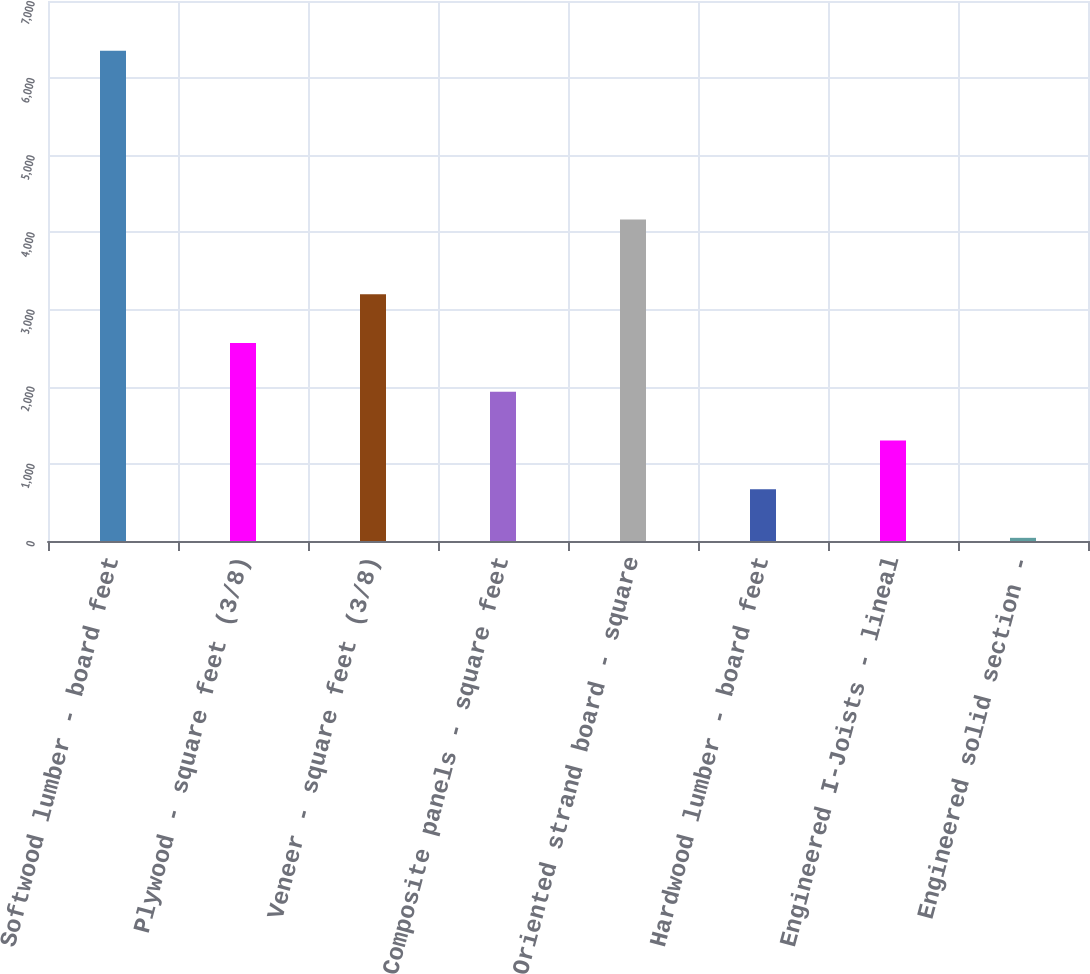Convert chart to OTSL. <chart><loc_0><loc_0><loc_500><loc_500><bar_chart><fcel>Softwood lumber - board feet<fcel>Plywood - square feet (3/8)<fcel>Veneer - square feet (3/8)<fcel>Composite panels - square feet<fcel>Oriented strand board - square<fcel>Hardwood lumber - board feet<fcel>Engineered I-Joists - lineal<fcel>Engineered solid section -<nl><fcel>6355<fcel>2566.6<fcel>3198<fcel>1935.2<fcel>4166<fcel>672.4<fcel>1303.8<fcel>41<nl></chart> 